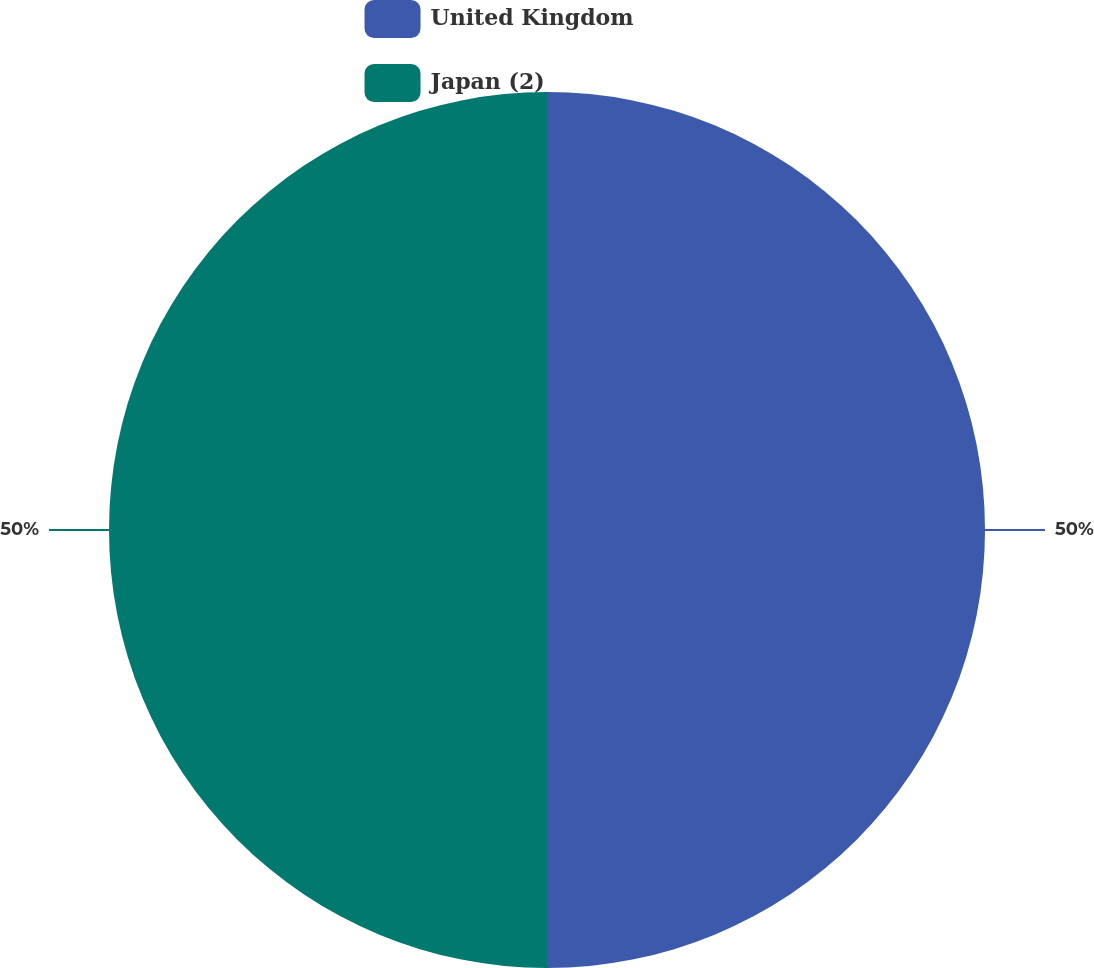<chart> <loc_0><loc_0><loc_500><loc_500><pie_chart><fcel>United Kingdom<fcel>Japan (2)<nl><fcel>50.0%<fcel>50.0%<nl></chart> 